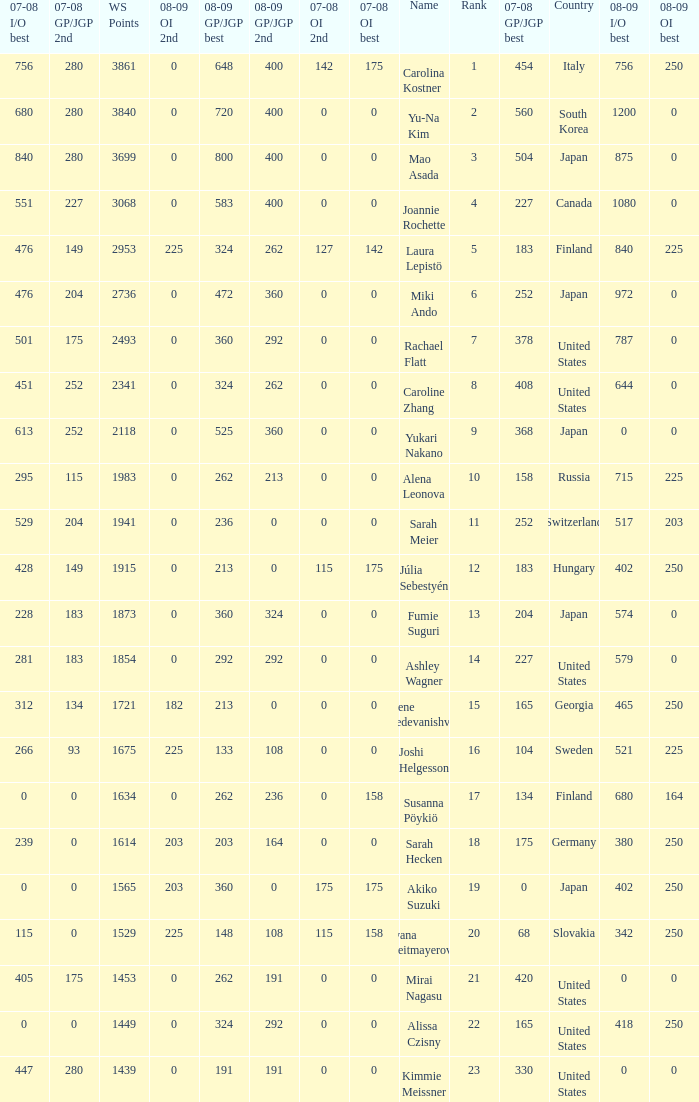08-09 gp/jgp 2nd is 213 and ws points will be what maximum 1983.0. 